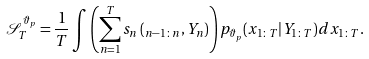<formula> <loc_0><loc_0><loc_500><loc_500>\mathcal { S } _ { T } ^ { \vartheta _ { p } } = \frac { 1 } { T } \int \left ( \sum _ { n = 1 } ^ { T } s _ { n } \left ( _ { n - 1 \colon n } , Y _ { n } \right ) \right ) p _ { \vartheta _ { p } } ( x _ { 1 \colon T } | Y _ { 1 \colon T } ) d x _ { 1 \colon T } .</formula> 